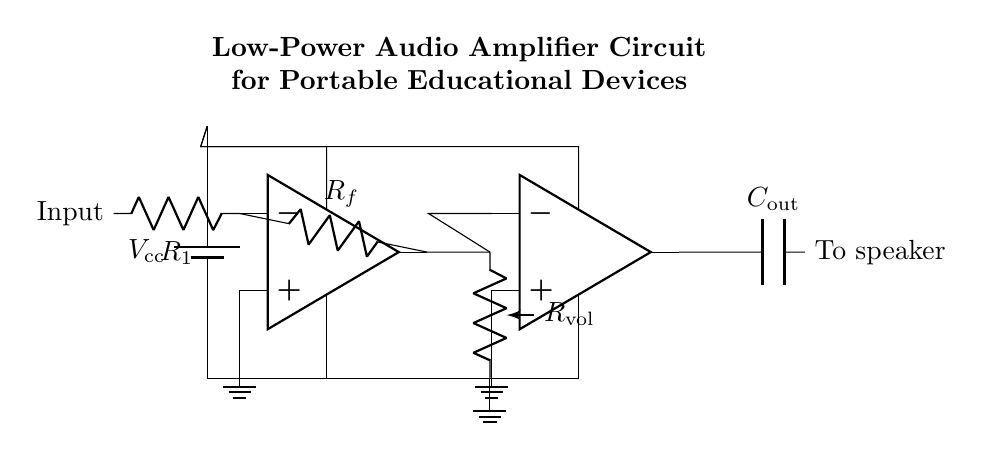What type of circuit is this? This is a low-power audio amplifier circuit, as indicated by its components and their arrangement designed to boost audio signals for portable devices.
Answer: low-power audio amplifier How many operational amplifiers are used in the circuit? The circuit contains two operational amplifiers, which are the main components for amplifying the audio signal.
Answer: two What is the role of the capacitor in this circuit? The capacitor is used as a coupling component, allowing the audio signal to pass through while blocking any DC offset, ensuring that only the AC audio signal reaches the speaker.
Answer: To speaker What is the function of the volume control resistor? The volume control resistor adjusts the amplitude of the audio signal before it is amplified by the second operational amplifier, allowing for user control over the output volume.
Answer: Adjust volume What happens to the signal at the output of the second operational amplifier? The output of the second operational amplifier sends the amplified audio signal through the capacitor to the speaker, converting the electrical signal back into sound.
Answer: Amplified audio What is the significance of the resistors R1 and Rf in the first operational amplifier? Resistors R1 and Rf set the gain of the first operational amplifier, determining how much the input signal is amplified before it reaches the next stage, directly impacting the overall audio output level.
Answer: Set gain 